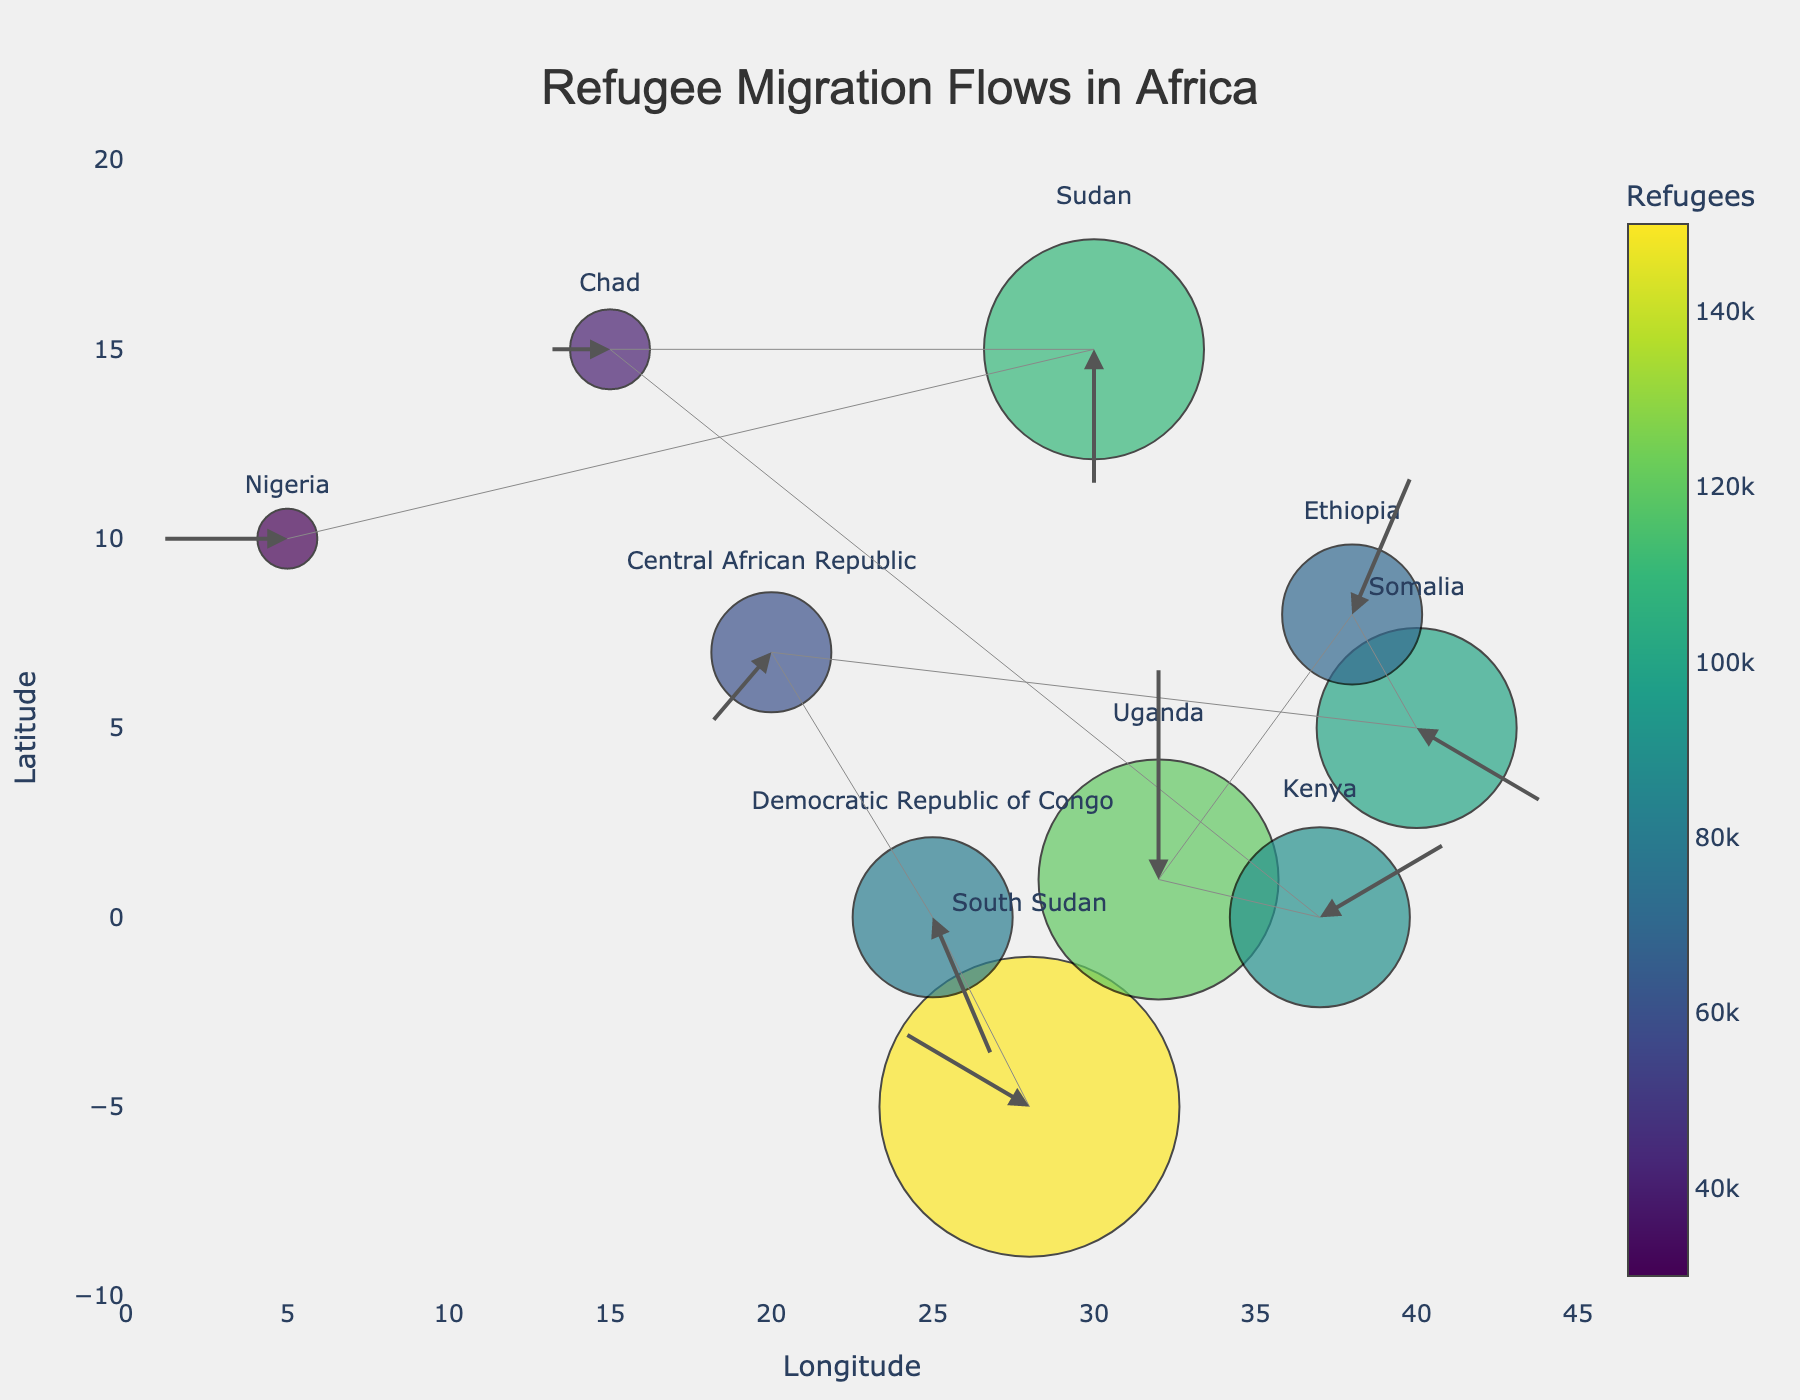What is the title of the plot? The title of the plot can usually be found at the top. Here, it reads 'Refugee Migration Flows in Africa'.
Answer: Refugee Migration Flows in Africa Which country has the largest circle, indicating the highest number of refugees? The largest circle represents the country with the highest number of refugees. According to the color scale and marker size, South Sudan has the largest circle with 150,000 refugees.
Answer: South Sudan What is the range of the longitude axis? The longitude axis is represented by the x-axis. By looking at the x-axis labels, it ranges from 0 to 45.
Answer: 0 to 45 Which country is represented by the arrow pointing upwards (positive V value)? An arrow pointing upwards has a positive V value. Uganda has an arrow pointing upwards from (32, 1) with a V value of 3, indicating an upward direction.
Answer: Uganda Which country has the smallest number of refugees? The smallest number of refugees is represented by the smallest circle and its color. According to the plot and color scale, Nigeria has the smallest circle indicating 30,000 refugees.
Answer: Nigeria How many countries have their arrows pointing leftwards (negative U value)? Countries with an arrow pointing leftwards will have a negative U value. By examining the arrows, the countries are South Sudan, Central African Republic, Chad, and Nigeria, making a total of 4 countries.
Answer: 4 Which country’s arrow points downwards and slightly to the left? An arrow pointing downwards and slightly to the left would have a negative V and slightly negative U value. Democratic Republic of Congo has an arrow from (25, 0) with U=1 and V=-2, indicating this direction.
Answer: Democratic Republic of Congo Compare the number of refugees between Ethiopia and Somalia. Which country has more? By comparing the circle sizes and refugee numbers, Somalia has 100,000 refugees while Ethiopia has 70,000 refugees.
Answer: Somalia How many countries have arrows pointing towards the right? Arrows pointing towards the right have a positive U value. By checking the plot, the countries are Democratic Republic of Congo, Ethiopia, Somalia, and Kenya, making it 4 countries.
Answer: 4 What is the total number of refugees represented in the plot? To find the total number of refugees, sum up all the refugee numbers given for each country: 150,000 (South Sudan) + 80,000 (Democratic Republic of Congo) + 60,000 (Central African Republic) + 100,000 (Somalia) + 70,000 (Ethiopia) + 120,000 (Uganda) + 90,000 (Kenya) + 40,000 (Chad) + 110,000 (Sudan) + 30,000 (Nigeria). The total is 850,000.
Answer: 850,000 